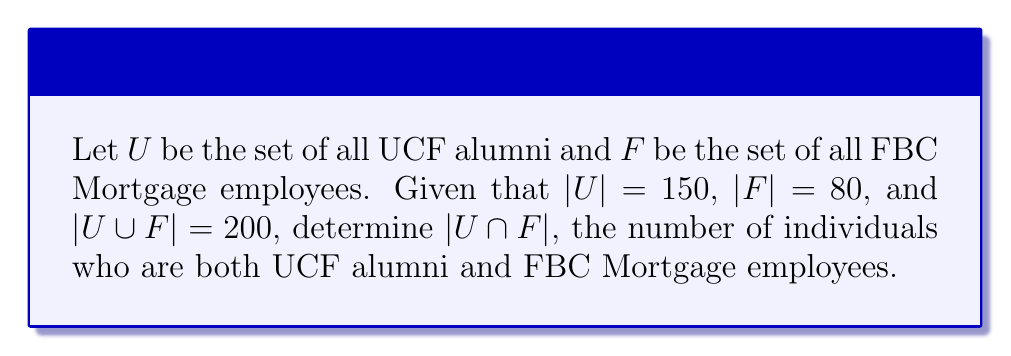Show me your answer to this math problem. To solve this problem, we'll use the following steps:

1) Recall the formula for the number of elements in the union of two sets:

   $|U \cup F| = |U| + |F| - |U \cap F|$

2) We're given the following information:
   $|U| = 150$
   $|F| = 80$
   $|U \cup F| = 200$

3) Let's substitute these values into our formula:

   $200 = 150 + 80 - |U \cap F|$

4) Now we can solve for $|U \cap F|$:

   $200 = 230 - |U \cap F|$
   $|U \cap F| = 230 - 200$
   $|U \cap F| = 30$

5) We can verify this result using a Venn diagram:

[asy]
unitsize(1cm);
path c1 = circle((0,0),2);
path c2 = circle((1,0),2);
fill(c1,rgb(0.9,0.9,1));
fill(c2,rgb(0.9,1,0.9));
fill(c1,rgb(0.8,1,0.8));
draw(c1);
draw(c2);
label("U", (-1.5,0));
label("F", (2.5,0));
label("120", (-1,0));
label("30", (0.5,0));
label("50", (2,0));
[/asy]

This diagram shows 120 UCF alumni who don't work at FBC Mortgage, 50 FBC Mortgage employees who aren't UCF alumni, and 30 individuals in the intersection.
Answer: $|U \cap F| = 30$ 